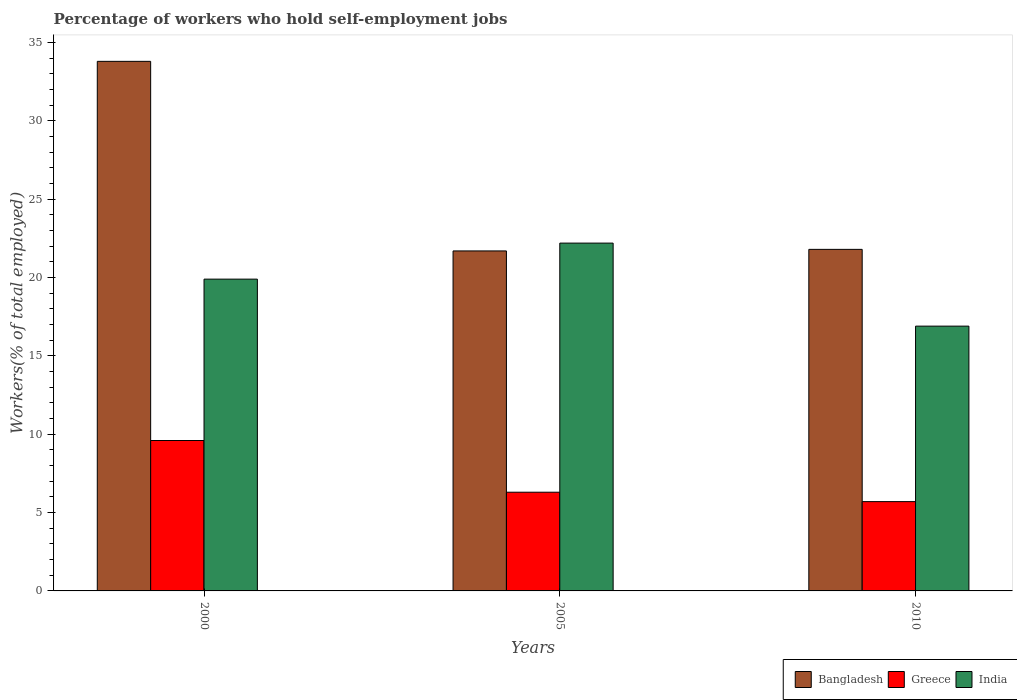Are the number of bars per tick equal to the number of legend labels?
Offer a terse response. Yes. How many bars are there on the 2nd tick from the left?
Your answer should be very brief. 3. What is the label of the 3rd group of bars from the left?
Provide a succinct answer. 2010. What is the percentage of self-employed workers in Greece in 2005?
Offer a terse response. 6.3. Across all years, what is the maximum percentage of self-employed workers in India?
Your response must be concise. 22.2. Across all years, what is the minimum percentage of self-employed workers in Greece?
Provide a succinct answer. 5.7. In which year was the percentage of self-employed workers in India minimum?
Ensure brevity in your answer.  2010. What is the total percentage of self-employed workers in India in the graph?
Offer a very short reply. 59. What is the difference between the percentage of self-employed workers in Greece in 2005 and that in 2010?
Your answer should be very brief. 0.6. What is the difference between the percentage of self-employed workers in India in 2010 and the percentage of self-employed workers in Greece in 2005?
Offer a terse response. 10.6. What is the average percentage of self-employed workers in Greece per year?
Provide a short and direct response. 7.2. In the year 2000, what is the difference between the percentage of self-employed workers in India and percentage of self-employed workers in Greece?
Keep it short and to the point. 10.3. In how many years, is the percentage of self-employed workers in India greater than 26 %?
Provide a short and direct response. 0. What is the ratio of the percentage of self-employed workers in India in 2005 to that in 2010?
Your answer should be very brief. 1.31. Is the percentage of self-employed workers in Greece in 2000 less than that in 2010?
Your answer should be very brief. No. What is the difference between the highest and the second highest percentage of self-employed workers in Bangladesh?
Keep it short and to the point. 12. What is the difference between the highest and the lowest percentage of self-employed workers in Greece?
Offer a very short reply. 3.9. Is the sum of the percentage of self-employed workers in Bangladesh in 2005 and 2010 greater than the maximum percentage of self-employed workers in Greece across all years?
Keep it short and to the point. Yes. What does the 1st bar from the left in 2000 represents?
Provide a succinct answer. Bangladesh. What does the 1st bar from the right in 2010 represents?
Your answer should be compact. India. How many years are there in the graph?
Provide a short and direct response. 3. What is the difference between two consecutive major ticks on the Y-axis?
Provide a succinct answer. 5. Are the values on the major ticks of Y-axis written in scientific E-notation?
Provide a short and direct response. No. Does the graph contain grids?
Provide a short and direct response. No. What is the title of the graph?
Your answer should be very brief. Percentage of workers who hold self-employment jobs. What is the label or title of the Y-axis?
Keep it short and to the point. Workers(% of total employed). What is the Workers(% of total employed) in Bangladesh in 2000?
Give a very brief answer. 33.8. What is the Workers(% of total employed) of Greece in 2000?
Your answer should be compact. 9.6. What is the Workers(% of total employed) in India in 2000?
Give a very brief answer. 19.9. What is the Workers(% of total employed) in Bangladesh in 2005?
Your response must be concise. 21.7. What is the Workers(% of total employed) of Greece in 2005?
Provide a short and direct response. 6.3. What is the Workers(% of total employed) of India in 2005?
Provide a short and direct response. 22.2. What is the Workers(% of total employed) in Bangladesh in 2010?
Provide a short and direct response. 21.8. What is the Workers(% of total employed) of Greece in 2010?
Provide a succinct answer. 5.7. What is the Workers(% of total employed) of India in 2010?
Your answer should be very brief. 16.9. Across all years, what is the maximum Workers(% of total employed) in Bangladesh?
Give a very brief answer. 33.8. Across all years, what is the maximum Workers(% of total employed) of Greece?
Your response must be concise. 9.6. Across all years, what is the maximum Workers(% of total employed) in India?
Give a very brief answer. 22.2. Across all years, what is the minimum Workers(% of total employed) in Bangladesh?
Your answer should be compact. 21.7. Across all years, what is the minimum Workers(% of total employed) of Greece?
Your answer should be compact. 5.7. Across all years, what is the minimum Workers(% of total employed) of India?
Give a very brief answer. 16.9. What is the total Workers(% of total employed) of Bangladesh in the graph?
Give a very brief answer. 77.3. What is the total Workers(% of total employed) of Greece in the graph?
Offer a very short reply. 21.6. What is the total Workers(% of total employed) of India in the graph?
Your answer should be compact. 59. What is the difference between the Workers(% of total employed) in Greece in 2000 and that in 2005?
Your response must be concise. 3.3. What is the difference between the Workers(% of total employed) of Bangladesh in 2000 and the Workers(% of total employed) of Greece in 2005?
Provide a succinct answer. 27.5. What is the difference between the Workers(% of total employed) in Bangladesh in 2000 and the Workers(% of total employed) in Greece in 2010?
Keep it short and to the point. 28.1. What is the difference between the Workers(% of total employed) of Bangladesh in 2000 and the Workers(% of total employed) of India in 2010?
Provide a succinct answer. 16.9. What is the difference between the Workers(% of total employed) in Greece in 2000 and the Workers(% of total employed) in India in 2010?
Offer a terse response. -7.3. What is the difference between the Workers(% of total employed) of Bangladesh in 2005 and the Workers(% of total employed) of Greece in 2010?
Your answer should be compact. 16. What is the difference between the Workers(% of total employed) of Bangladesh in 2005 and the Workers(% of total employed) of India in 2010?
Provide a short and direct response. 4.8. What is the average Workers(% of total employed) of Bangladesh per year?
Ensure brevity in your answer.  25.77. What is the average Workers(% of total employed) of India per year?
Offer a very short reply. 19.67. In the year 2000, what is the difference between the Workers(% of total employed) in Bangladesh and Workers(% of total employed) in Greece?
Your answer should be compact. 24.2. In the year 2005, what is the difference between the Workers(% of total employed) in Bangladesh and Workers(% of total employed) in Greece?
Your answer should be very brief. 15.4. In the year 2005, what is the difference between the Workers(% of total employed) of Greece and Workers(% of total employed) of India?
Your answer should be very brief. -15.9. In the year 2010, what is the difference between the Workers(% of total employed) in Bangladesh and Workers(% of total employed) in India?
Offer a very short reply. 4.9. What is the ratio of the Workers(% of total employed) of Bangladesh in 2000 to that in 2005?
Your response must be concise. 1.56. What is the ratio of the Workers(% of total employed) in Greece in 2000 to that in 2005?
Your response must be concise. 1.52. What is the ratio of the Workers(% of total employed) of India in 2000 to that in 2005?
Provide a short and direct response. 0.9. What is the ratio of the Workers(% of total employed) in Bangladesh in 2000 to that in 2010?
Provide a succinct answer. 1.55. What is the ratio of the Workers(% of total employed) in Greece in 2000 to that in 2010?
Offer a very short reply. 1.68. What is the ratio of the Workers(% of total employed) of India in 2000 to that in 2010?
Keep it short and to the point. 1.18. What is the ratio of the Workers(% of total employed) in Greece in 2005 to that in 2010?
Ensure brevity in your answer.  1.11. What is the ratio of the Workers(% of total employed) of India in 2005 to that in 2010?
Give a very brief answer. 1.31. What is the difference between the highest and the lowest Workers(% of total employed) of Greece?
Keep it short and to the point. 3.9. What is the difference between the highest and the lowest Workers(% of total employed) of India?
Your answer should be very brief. 5.3. 